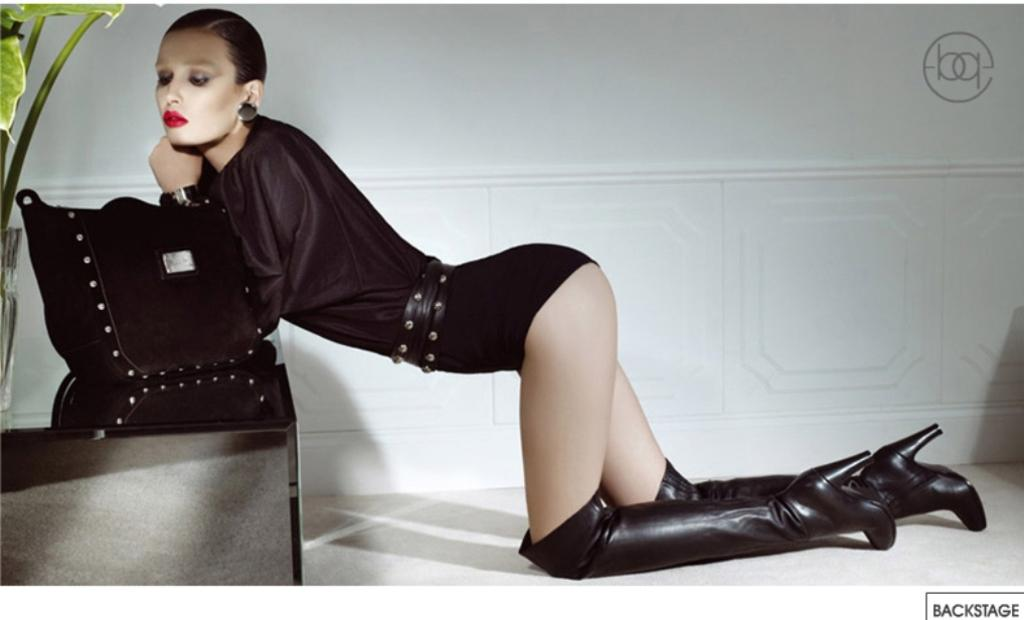What is the main subject of the image? The main subject of the image is women. What position are the women in? The women are in a squat position. What can be seen in the background of the image? There is a wall in the background of the image. What type of government is depicted in the image? There is no depiction of a government in the image; it features women in a squat position with a wall in the background. What type of wax is being used by the women in the image? There is no wax present in the image, nor are the women using any wax. 